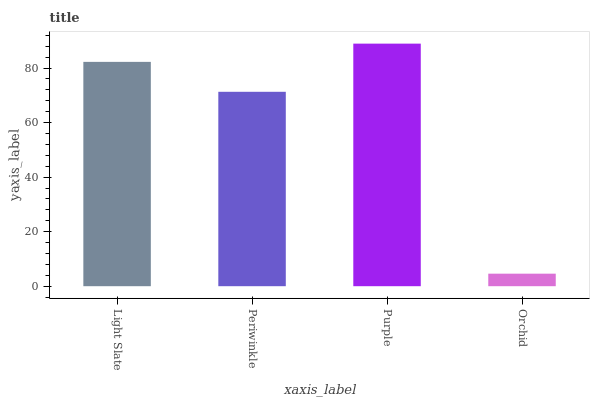Is Orchid the minimum?
Answer yes or no. Yes. Is Purple the maximum?
Answer yes or no. Yes. Is Periwinkle the minimum?
Answer yes or no. No. Is Periwinkle the maximum?
Answer yes or no. No. Is Light Slate greater than Periwinkle?
Answer yes or no. Yes. Is Periwinkle less than Light Slate?
Answer yes or no. Yes. Is Periwinkle greater than Light Slate?
Answer yes or no. No. Is Light Slate less than Periwinkle?
Answer yes or no. No. Is Light Slate the high median?
Answer yes or no. Yes. Is Periwinkle the low median?
Answer yes or no. Yes. Is Orchid the high median?
Answer yes or no. No. Is Light Slate the low median?
Answer yes or no. No. 